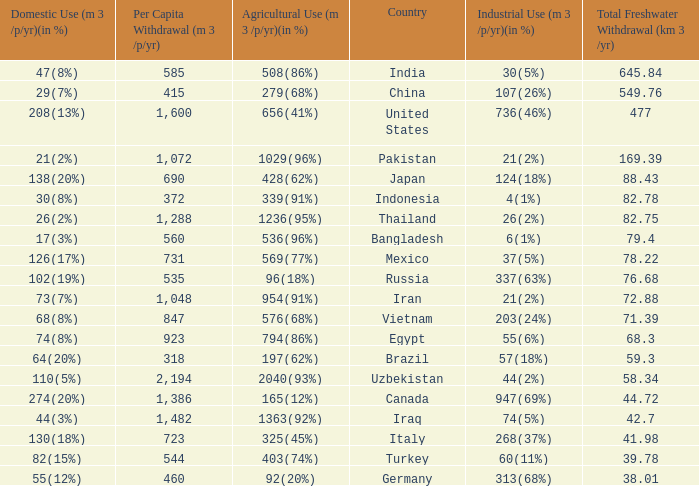What is Industrial Use (m 3 /p/yr)(in %), when Total Freshwater Withdrawal (km 3/yr) is less than 82.75, and when Agricultural Use (m 3 /p/yr)(in %) is 1363(92%)? 74(5%). 